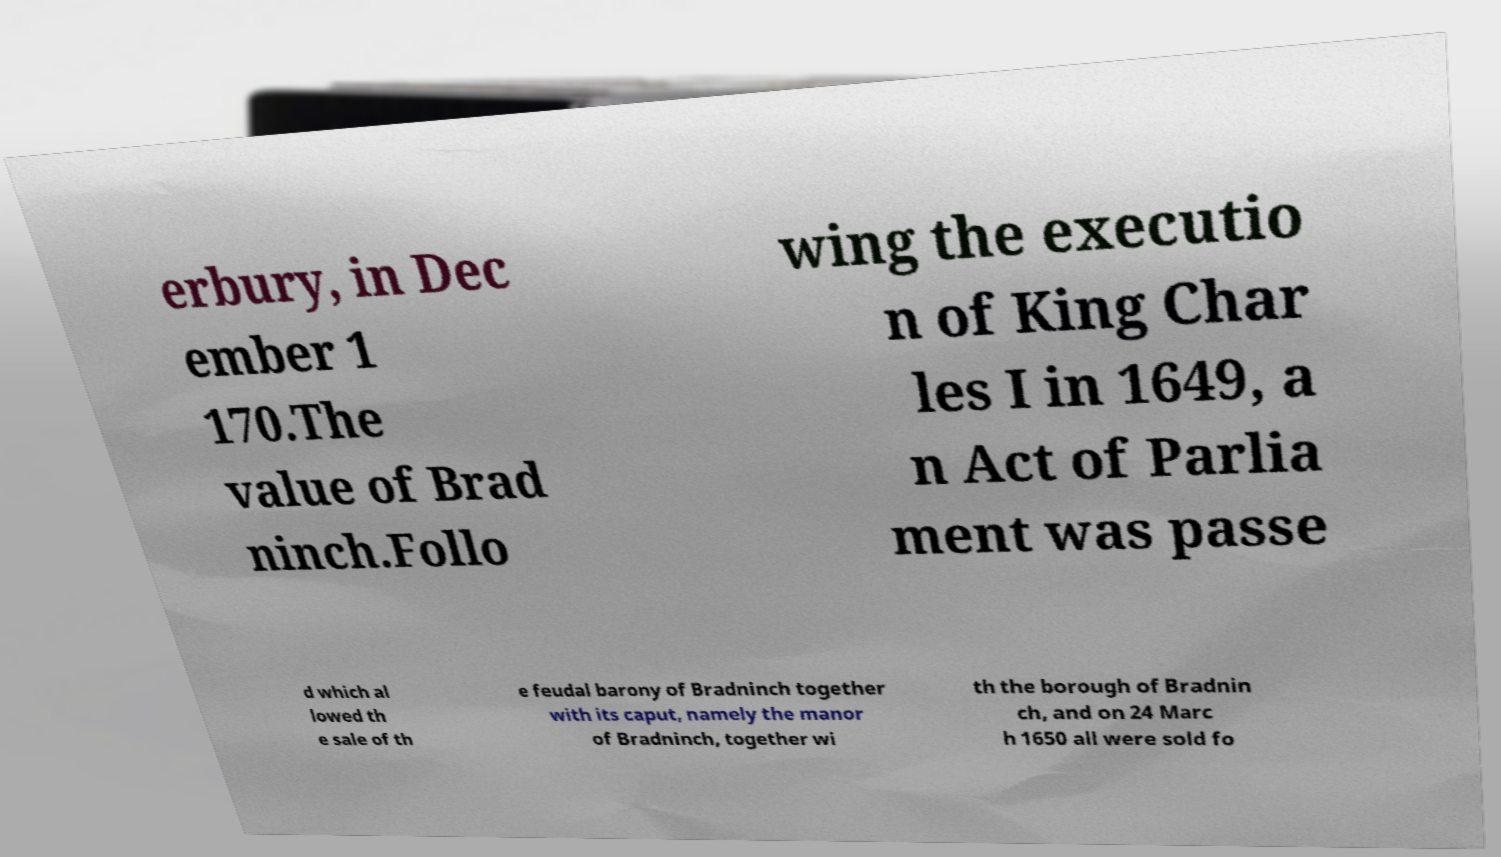What messages or text are displayed in this image? I need them in a readable, typed format. erbury, in Dec ember 1 170.The value of Brad ninch.Follo wing the executio n of King Char les I in 1649, a n Act of Parlia ment was passe d which al lowed th e sale of th e feudal barony of Bradninch together with its caput, namely the manor of Bradninch, together wi th the borough of Bradnin ch, and on 24 Marc h 1650 all were sold fo 